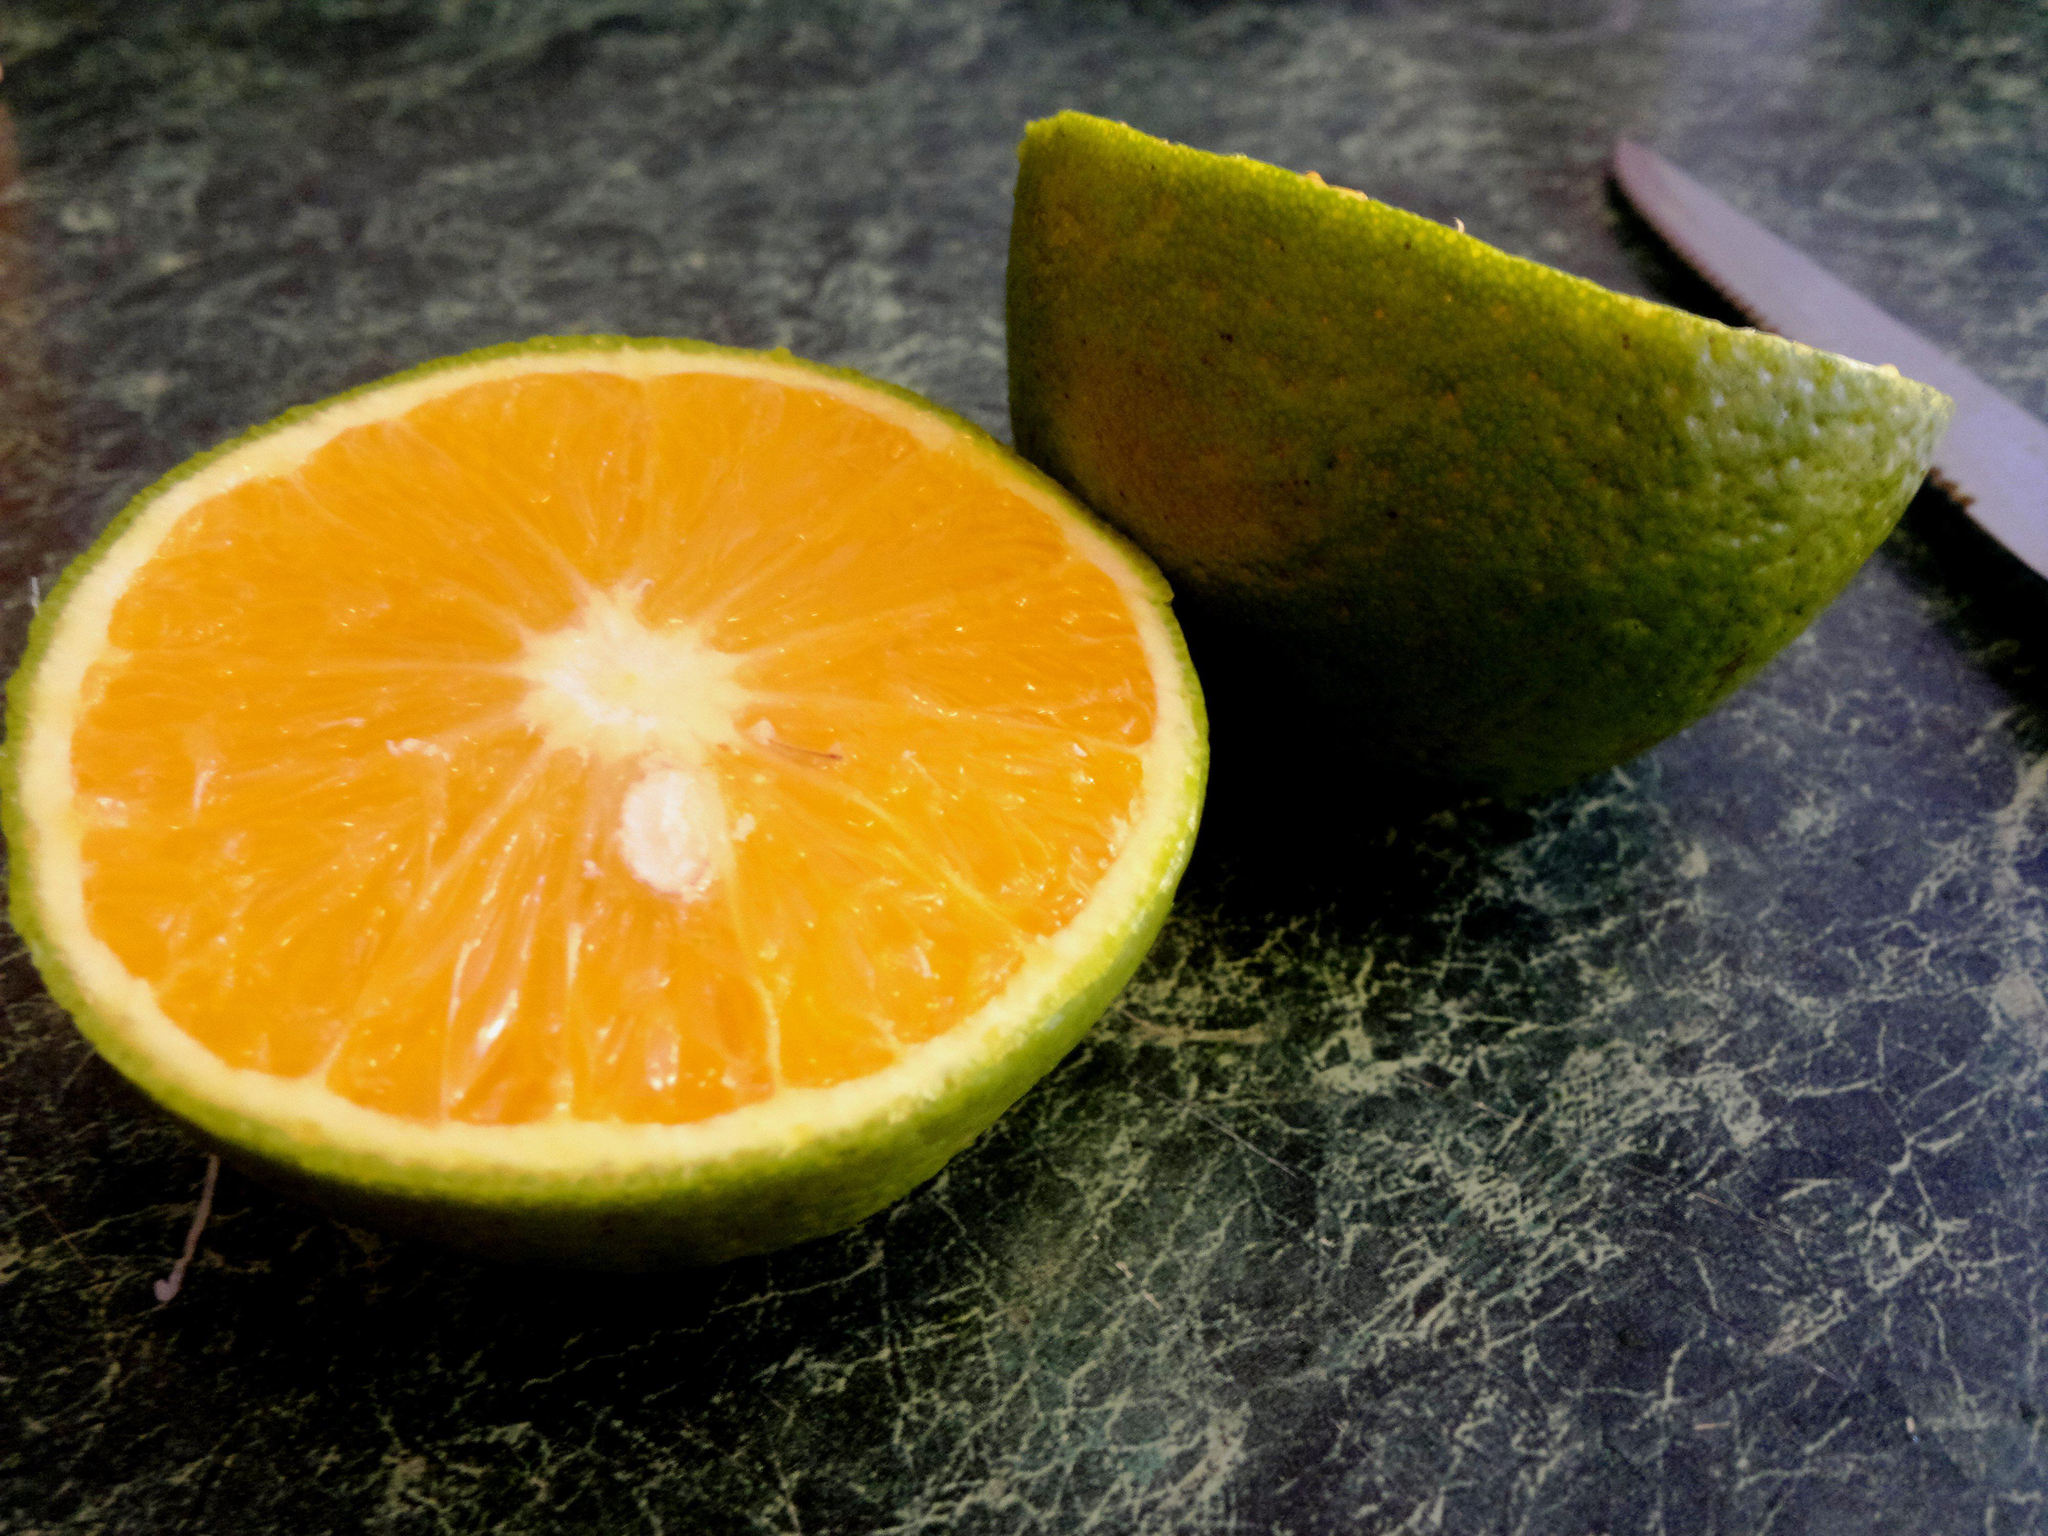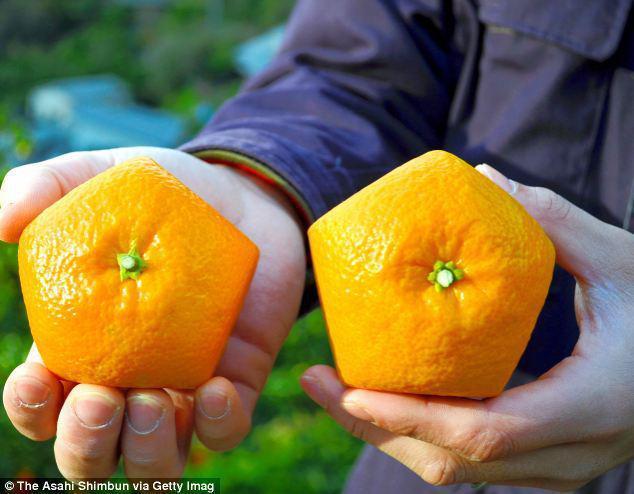The first image is the image on the left, the second image is the image on the right. Considering the images on both sides, is "In one of the images there are at least three oranges still attached to the tree." valid? Answer yes or no. No. The first image is the image on the left, the second image is the image on the right. Analyze the images presented: Is the assertion "A fruit with a green skin is revealing an orange inside in one of the images." valid? Answer yes or no. Yes. 